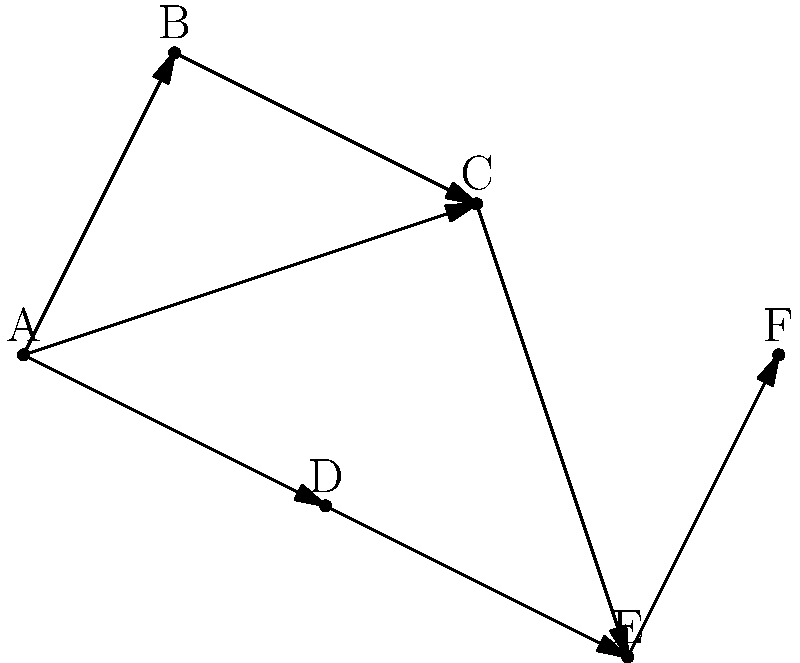In the network diagram above, what is the shortest path from node A to node F in terms of the number of edges traversed? List the nodes in order. To find the shortest path from node A to node F, we need to analyze all possible paths and count the number of edges traversed. Let's break it down step-by-step:

1. Identify all possible paths from A to F:
   - A → B → C → E → F
   - A → C → E → F
   - A → D → E → F

2. Count the number of edges for each path:
   - A → B → C → E → F: 4 edges
   - A → C → E → F: 3 edges
   - A → D → E → F: 3 edges

3. Compare the number of edges:
   Both A → C → E → F and A → D → E → F have the fewest edges (3).

4. Choose one of the shortest paths:
   For this question, we'll select A → C → E → F as the answer.

The shortest path from A to F is A → C → E → F, which traverses 3 edges.
Answer: A → C → E → F 